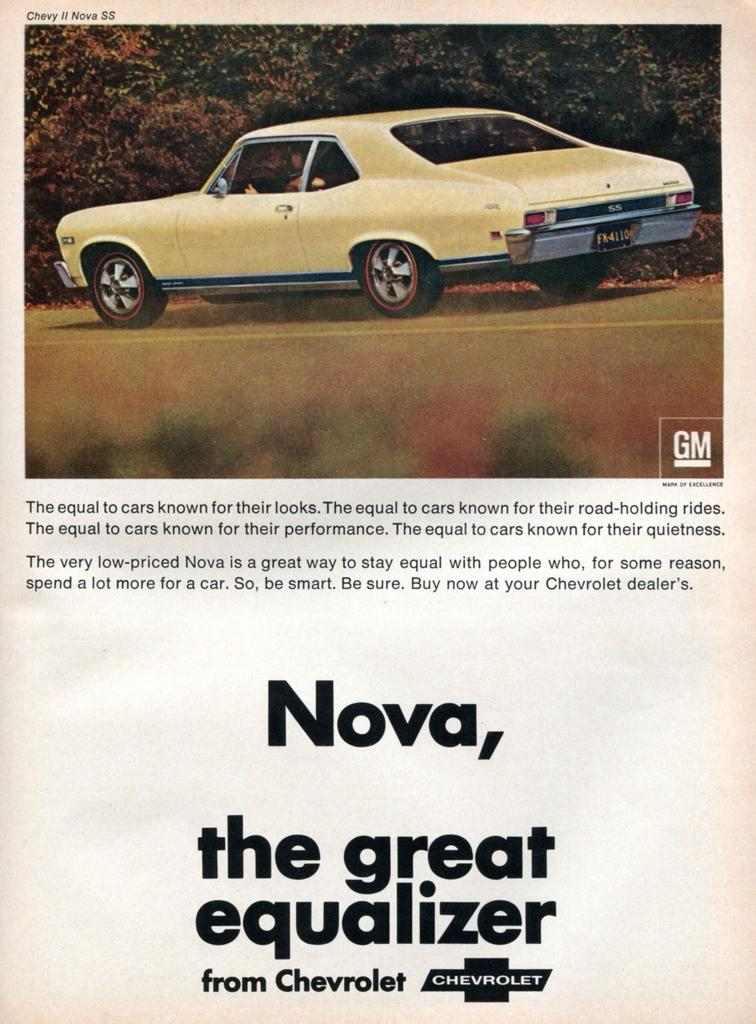What is present on the paper in the image? There is text on the paper in the image. What type of natural elements can be seen in the image? There are trees and plants in the image. What is the main mode of transportation visible in the image? There is a car on the ground in the image. What is the color of the background in the image? The background of the image is white in color. Where is the scarecrow located in the image? There is no scarecrow present in the image. What advice does the grandfather give in the image? There is no grandfather present in the image, so no advice can be given. 